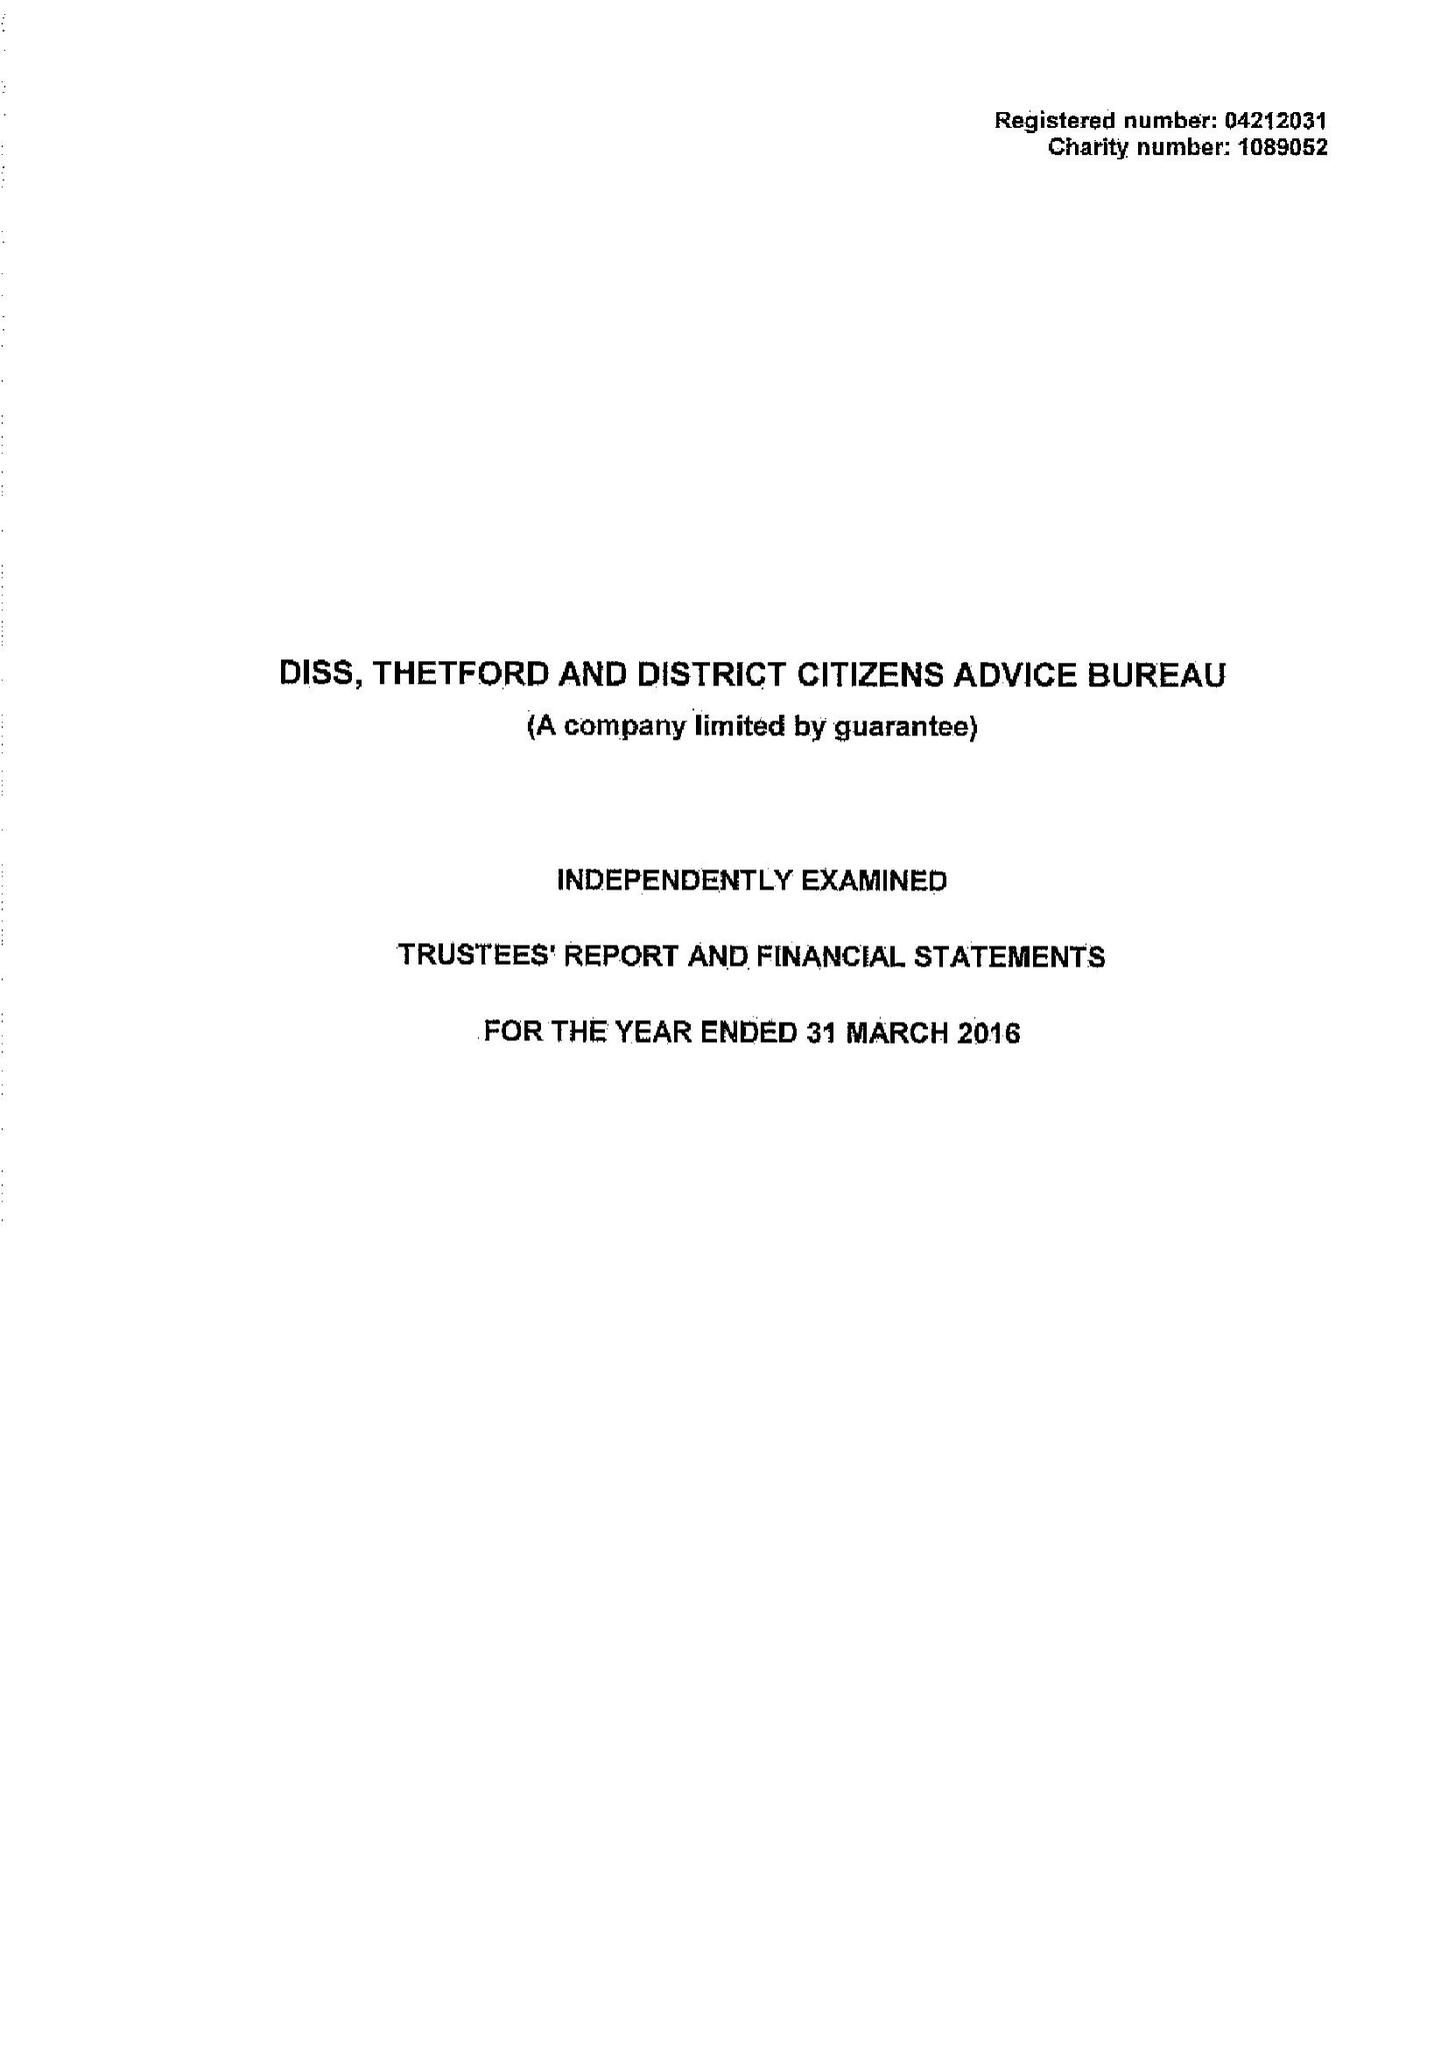What is the value for the address__postcode?
Answer the question using a single word or phrase. IP22 4EH 